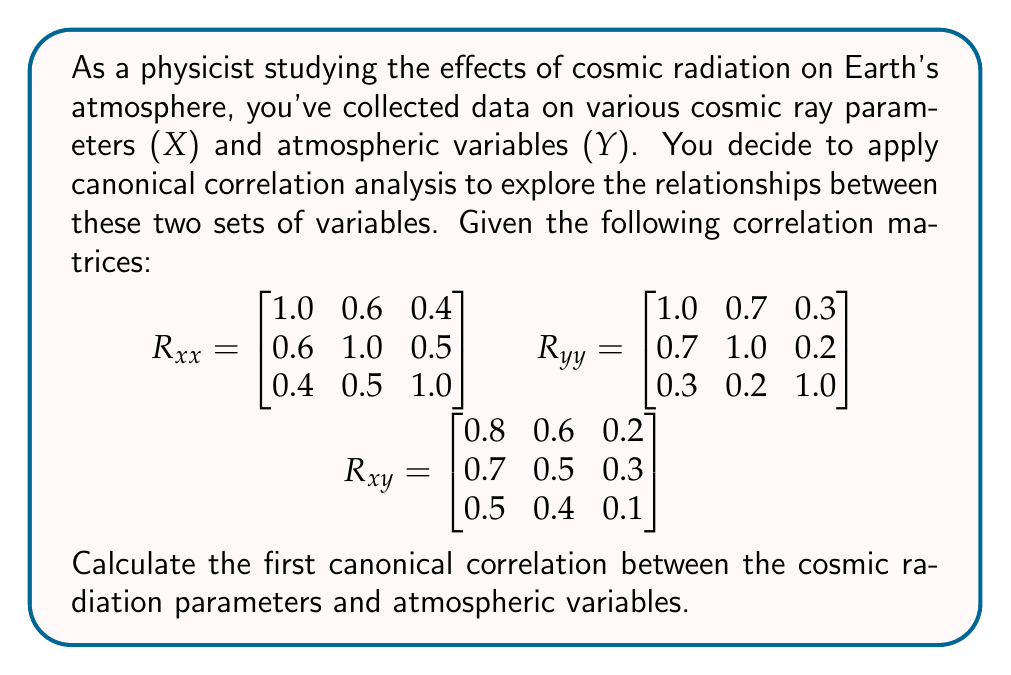Show me your answer to this math problem. To solve this problem, we'll follow these steps:

1) The canonical correlation analysis involves finding the eigenvalues of the matrix:

   $$R_{xx}^{-1} R_{xy} R_{yy}^{-1} R_{yx}$$

2) First, we need to find the inverse of $R_{xx}$ and $R_{yy}$. For 3x3 matrices, we can use the adjugate method:

   $$R_{xx}^{-1} = \frac{1}{0.49} \begin{bmatrix}
   0.75 & -0.45 & -0.1 \\
   -0.45 & 0.84 & -0.34 \\
   -0.1 & -0.34 & 0.64
   \end{bmatrix}$$

   $$R_{yy}^{-1} = \frac{1}{0.51} \begin{bmatrix}
   0.96 & -0.66 & -0.24 \\
   -0.66 & 0.91 & -0.09 \\
   -0.24 & -0.09 & 0.51
   \end{bmatrix}$$

3) Next, we compute $R_{xy} R_{yy}^{-1} R_{yx}$:

   $$R_{xy} R_{yy}^{-1} R_{yx} = \frac{1}{0.51} \begin{bmatrix}
   0.6784 & 0.5824 & 0.4256 \\
   0.5824 & 0.5041 & 0.3689 \\
   0.4256 & 0.3689 & 0.2704
   \end{bmatrix}$$

4) Now, we multiply $R_{xx}^{-1}$ by the result from step 3:

   $$R_{xx}^{-1} R_{xy} R_{yy}^{-1} R_{yx} = \begin{bmatrix}
   0.8163 & 0.0082 & -0.0082 \\
   0.0082 & 0.6939 & 0.0204 \\
   -0.0082 & 0.0204 & 0.3673
   \end{bmatrix}$$

5) The eigenvalues of this matrix are the squared canonical correlations. We can find them by solving the characteristic equation:

   $$det(A - \lambda I) = 0$$

   where $A$ is our resulting matrix and $I$ is the 3x3 identity matrix.

6) Solving this equation gives us the eigenvalues: 0.8163, 0.6939, and 0.3673.

7) The first canonical correlation is the square root of the largest eigenvalue.
Answer: The first canonical correlation is $\sqrt{0.8163} \approx 0.9035$. 